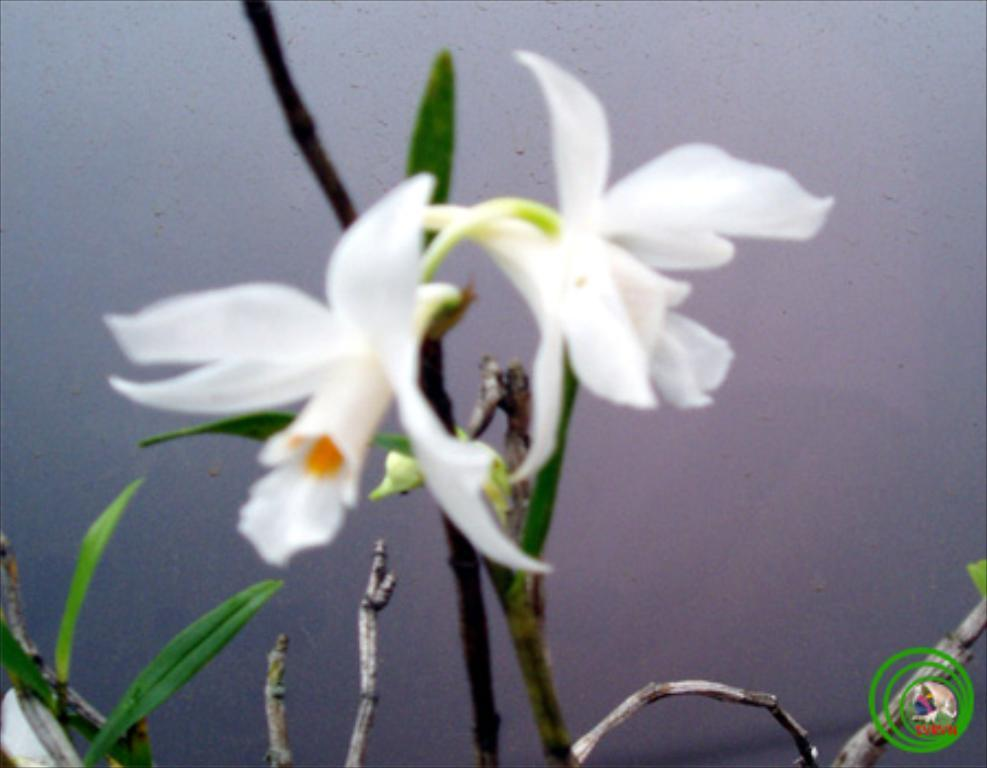What type of living organisms can be seen in the image? There are flowers in the image. To which plant do the flowers belong? The flowers belong to a plant. Where are the flowers located in the image? The flowers are in the center of the image. What type of toothpaste is used to clean the flowers in the image? There is no toothpaste present in the image, and flowers do not require cleaning with toothpaste. 